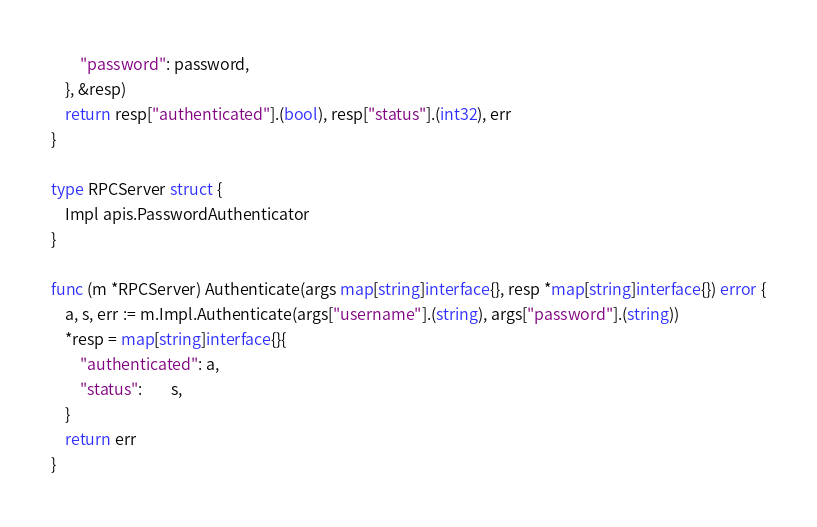<code> <loc_0><loc_0><loc_500><loc_500><_Go_>		"password": password,
	}, &resp)
	return resp["authenticated"].(bool), resp["status"].(int32), err
}

type RPCServer struct {
	Impl apis.PasswordAuthenticator
}

func (m *RPCServer) Authenticate(args map[string]interface{}, resp *map[string]interface{}) error {
	a, s, err := m.Impl.Authenticate(args["username"].(string), args["password"].(string))
	*resp = map[string]interface{}{
		"authenticated": a,
		"status":        s,
	}
	return err
}
</code> 